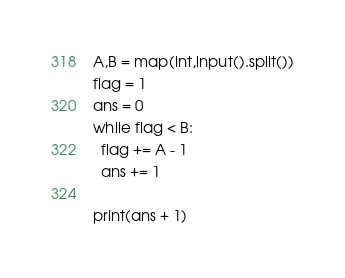<code> <loc_0><loc_0><loc_500><loc_500><_Python_>A,B = map(int,input().split())
flag = 1
ans = 0
while flag < B:
  flag += A - 1
  ans += 1
  
print(ans + 1)</code> 